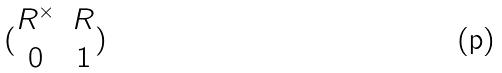Convert formula to latex. <formula><loc_0><loc_0><loc_500><loc_500>( \begin{matrix} R ^ { \times } & R \\ 0 & 1 \end{matrix} )</formula> 